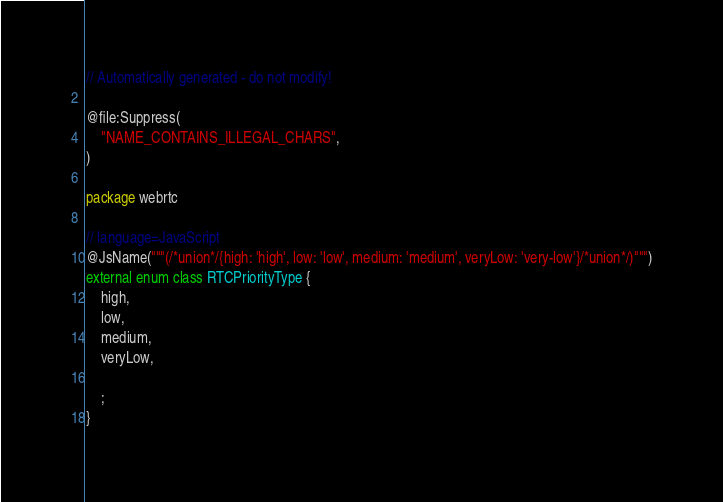<code> <loc_0><loc_0><loc_500><loc_500><_Kotlin_>// Automatically generated - do not modify!

@file:Suppress(
    "NAME_CONTAINS_ILLEGAL_CHARS",
)

package webrtc

// language=JavaScript
@JsName("""(/*union*/{high: 'high', low: 'low', medium: 'medium', veryLow: 'very-low'}/*union*/)""")
external enum class RTCPriorityType {
    high,
    low,
    medium,
    veryLow,

    ;
}
</code> 